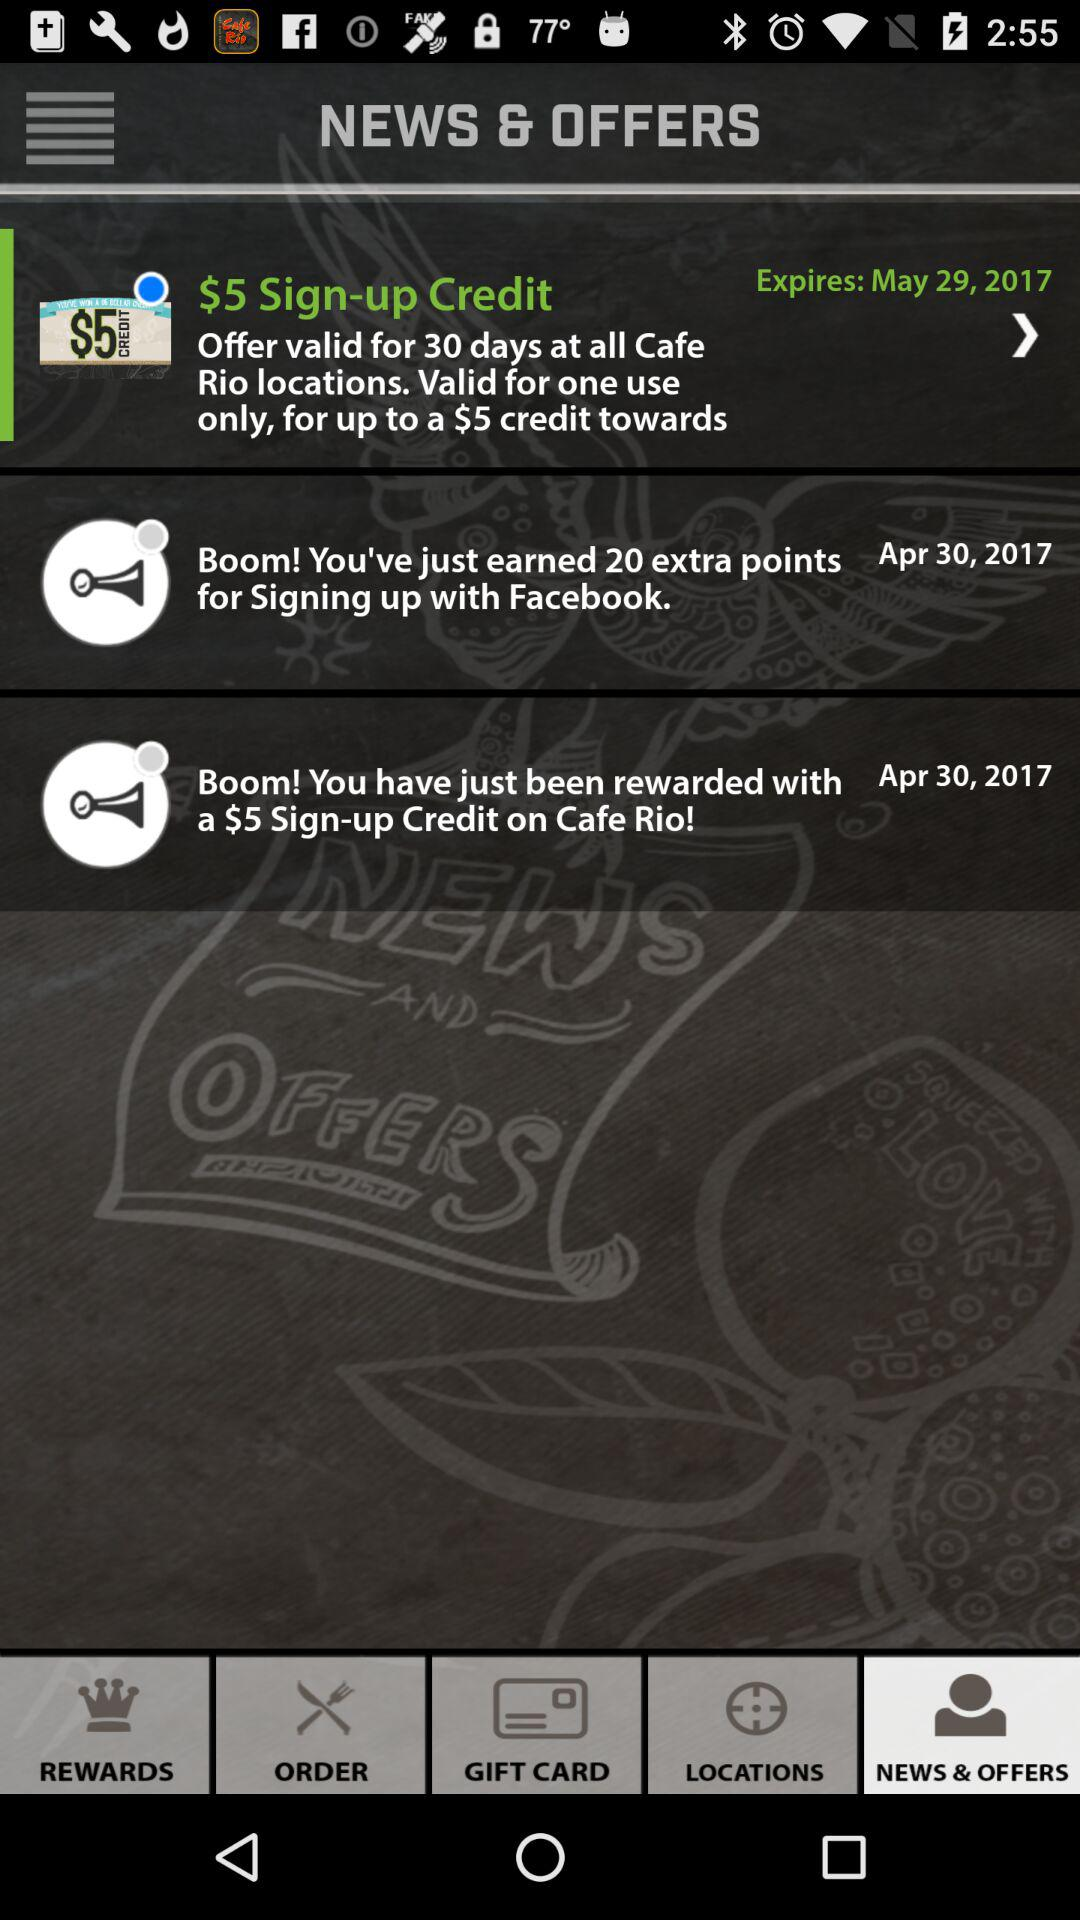How many points did the user earn for signing up with Facebook?
Answer the question using a single word or phrase. 20 